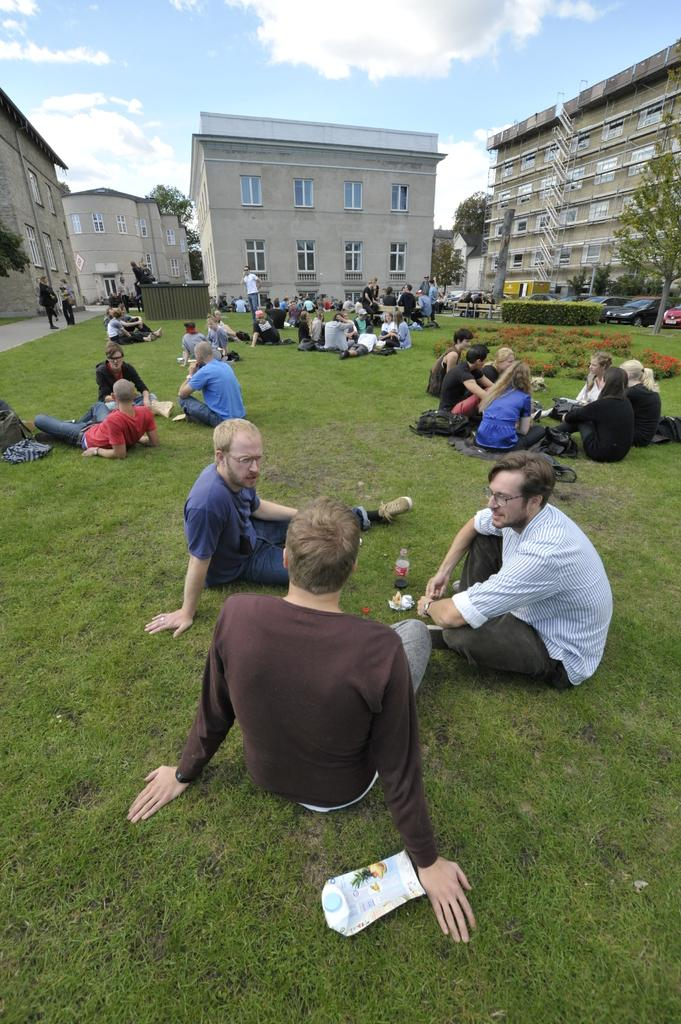What type of structures can be seen in the image? There are buildings in the image. What natural elements are present in the image? There are trees and grass visible in the image. Can you describe the people in the image? There are people in the image. What is visible in the background of the image? The sky is visible in the image, and clouds are present in the sky. What type of music is being played by the father in the image? There is no father or music present in the image. What decision is being made by the people in the image? There is no decision-making process depicted in the image. 